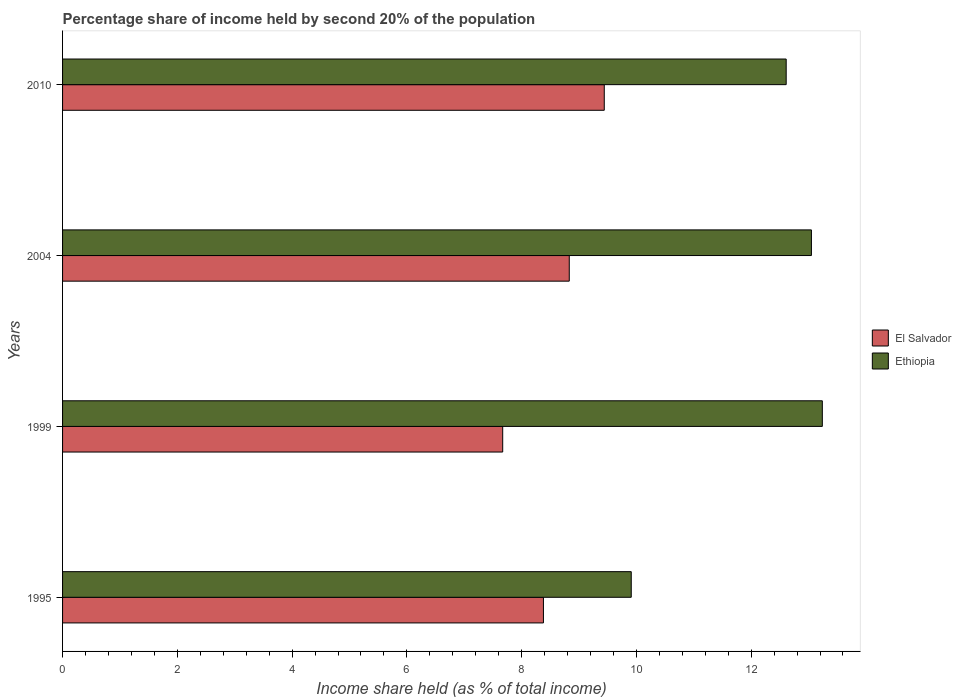How many different coloured bars are there?
Keep it short and to the point. 2. Are the number of bars per tick equal to the number of legend labels?
Offer a terse response. Yes. Are the number of bars on each tick of the Y-axis equal?
Keep it short and to the point. Yes. How many bars are there on the 3rd tick from the top?
Keep it short and to the point. 2. What is the label of the 3rd group of bars from the top?
Ensure brevity in your answer.  1999. What is the share of income held by second 20% of the population in Ethiopia in 2004?
Your answer should be compact. 13.05. Across all years, what is the maximum share of income held by second 20% of the population in Ethiopia?
Give a very brief answer. 13.24. Across all years, what is the minimum share of income held by second 20% of the population in Ethiopia?
Your answer should be compact. 9.91. In which year was the share of income held by second 20% of the population in Ethiopia maximum?
Keep it short and to the point. 1999. What is the total share of income held by second 20% of the population in Ethiopia in the graph?
Provide a short and direct response. 48.81. What is the difference between the share of income held by second 20% of the population in Ethiopia in 2004 and that in 2010?
Provide a short and direct response. 0.44. What is the difference between the share of income held by second 20% of the population in Ethiopia in 2010 and the share of income held by second 20% of the population in El Salvador in 1995?
Provide a succinct answer. 4.23. What is the average share of income held by second 20% of the population in Ethiopia per year?
Provide a succinct answer. 12.2. In the year 1999, what is the difference between the share of income held by second 20% of the population in Ethiopia and share of income held by second 20% of the population in El Salvador?
Keep it short and to the point. 5.57. In how many years, is the share of income held by second 20% of the population in Ethiopia greater than 5.6 %?
Your response must be concise. 4. What is the ratio of the share of income held by second 20% of the population in El Salvador in 1999 to that in 2004?
Ensure brevity in your answer.  0.87. Is the share of income held by second 20% of the population in El Salvador in 1999 less than that in 2004?
Provide a succinct answer. Yes. Is the difference between the share of income held by second 20% of the population in Ethiopia in 1999 and 2010 greater than the difference between the share of income held by second 20% of the population in El Salvador in 1999 and 2010?
Give a very brief answer. Yes. What is the difference between the highest and the second highest share of income held by second 20% of the population in El Salvador?
Offer a terse response. 0.61. What is the difference between the highest and the lowest share of income held by second 20% of the population in Ethiopia?
Keep it short and to the point. 3.33. In how many years, is the share of income held by second 20% of the population in El Salvador greater than the average share of income held by second 20% of the population in El Salvador taken over all years?
Provide a short and direct response. 2. What does the 1st bar from the top in 2004 represents?
Give a very brief answer. Ethiopia. What does the 2nd bar from the bottom in 2010 represents?
Your answer should be very brief. Ethiopia. What is the difference between two consecutive major ticks on the X-axis?
Your answer should be compact. 2. Does the graph contain any zero values?
Keep it short and to the point. No. Does the graph contain grids?
Make the answer very short. No. How many legend labels are there?
Provide a short and direct response. 2. What is the title of the graph?
Keep it short and to the point. Percentage share of income held by second 20% of the population. What is the label or title of the X-axis?
Your answer should be compact. Income share held (as % of total income). What is the Income share held (as % of total income) of El Salvador in 1995?
Your response must be concise. 8.38. What is the Income share held (as % of total income) of Ethiopia in 1995?
Offer a terse response. 9.91. What is the Income share held (as % of total income) of El Salvador in 1999?
Make the answer very short. 7.67. What is the Income share held (as % of total income) in Ethiopia in 1999?
Provide a short and direct response. 13.24. What is the Income share held (as % of total income) of El Salvador in 2004?
Ensure brevity in your answer.  8.83. What is the Income share held (as % of total income) in Ethiopia in 2004?
Offer a very short reply. 13.05. What is the Income share held (as % of total income) in El Salvador in 2010?
Make the answer very short. 9.44. What is the Income share held (as % of total income) in Ethiopia in 2010?
Your response must be concise. 12.61. Across all years, what is the maximum Income share held (as % of total income) in El Salvador?
Provide a succinct answer. 9.44. Across all years, what is the maximum Income share held (as % of total income) in Ethiopia?
Your answer should be compact. 13.24. Across all years, what is the minimum Income share held (as % of total income) in El Salvador?
Your answer should be very brief. 7.67. Across all years, what is the minimum Income share held (as % of total income) of Ethiopia?
Your answer should be very brief. 9.91. What is the total Income share held (as % of total income) of El Salvador in the graph?
Your answer should be very brief. 34.32. What is the total Income share held (as % of total income) in Ethiopia in the graph?
Offer a very short reply. 48.81. What is the difference between the Income share held (as % of total income) of El Salvador in 1995 and that in 1999?
Keep it short and to the point. 0.71. What is the difference between the Income share held (as % of total income) in Ethiopia in 1995 and that in 1999?
Your answer should be compact. -3.33. What is the difference between the Income share held (as % of total income) in El Salvador in 1995 and that in 2004?
Make the answer very short. -0.45. What is the difference between the Income share held (as % of total income) of Ethiopia in 1995 and that in 2004?
Offer a very short reply. -3.14. What is the difference between the Income share held (as % of total income) of El Salvador in 1995 and that in 2010?
Ensure brevity in your answer.  -1.06. What is the difference between the Income share held (as % of total income) in El Salvador in 1999 and that in 2004?
Give a very brief answer. -1.16. What is the difference between the Income share held (as % of total income) in Ethiopia in 1999 and that in 2004?
Provide a short and direct response. 0.19. What is the difference between the Income share held (as % of total income) of El Salvador in 1999 and that in 2010?
Your answer should be very brief. -1.77. What is the difference between the Income share held (as % of total income) of Ethiopia in 1999 and that in 2010?
Your answer should be compact. 0.63. What is the difference between the Income share held (as % of total income) of El Salvador in 2004 and that in 2010?
Ensure brevity in your answer.  -0.61. What is the difference between the Income share held (as % of total income) in Ethiopia in 2004 and that in 2010?
Ensure brevity in your answer.  0.44. What is the difference between the Income share held (as % of total income) of El Salvador in 1995 and the Income share held (as % of total income) of Ethiopia in 1999?
Give a very brief answer. -4.86. What is the difference between the Income share held (as % of total income) of El Salvador in 1995 and the Income share held (as % of total income) of Ethiopia in 2004?
Your answer should be compact. -4.67. What is the difference between the Income share held (as % of total income) of El Salvador in 1995 and the Income share held (as % of total income) of Ethiopia in 2010?
Make the answer very short. -4.23. What is the difference between the Income share held (as % of total income) of El Salvador in 1999 and the Income share held (as % of total income) of Ethiopia in 2004?
Keep it short and to the point. -5.38. What is the difference between the Income share held (as % of total income) in El Salvador in 1999 and the Income share held (as % of total income) in Ethiopia in 2010?
Provide a short and direct response. -4.94. What is the difference between the Income share held (as % of total income) of El Salvador in 2004 and the Income share held (as % of total income) of Ethiopia in 2010?
Give a very brief answer. -3.78. What is the average Income share held (as % of total income) of El Salvador per year?
Your answer should be compact. 8.58. What is the average Income share held (as % of total income) in Ethiopia per year?
Ensure brevity in your answer.  12.2. In the year 1995, what is the difference between the Income share held (as % of total income) in El Salvador and Income share held (as % of total income) in Ethiopia?
Provide a short and direct response. -1.53. In the year 1999, what is the difference between the Income share held (as % of total income) in El Salvador and Income share held (as % of total income) in Ethiopia?
Your response must be concise. -5.57. In the year 2004, what is the difference between the Income share held (as % of total income) in El Salvador and Income share held (as % of total income) in Ethiopia?
Provide a succinct answer. -4.22. In the year 2010, what is the difference between the Income share held (as % of total income) in El Salvador and Income share held (as % of total income) in Ethiopia?
Give a very brief answer. -3.17. What is the ratio of the Income share held (as % of total income) of El Salvador in 1995 to that in 1999?
Offer a very short reply. 1.09. What is the ratio of the Income share held (as % of total income) of Ethiopia in 1995 to that in 1999?
Offer a very short reply. 0.75. What is the ratio of the Income share held (as % of total income) of El Salvador in 1995 to that in 2004?
Keep it short and to the point. 0.95. What is the ratio of the Income share held (as % of total income) of Ethiopia in 1995 to that in 2004?
Provide a succinct answer. 0.76. What is the ratio of the Income share held (as % of total income) in El Salvador in 1995 to that in 2010?
Offer a very short reply. 0.89. What is the ratio of the Income share held (as % of total income) in Ethiopia in 1995 to that in 2010?
Offer a terse response. 0.79. What is the ratio of the Income share held (as % of total income) of El Salvador in 1999 to that in 2004?
Your answer should be compact. 0.87. What is the ratio of the Income share held (as % of total income) in Ethiopia in 1999 to that in 2004?
Provide a short and direct response. 1.01. What is the ratio of the Income share held (as % of total income) in El Salvador in 1999 to that in 2010?
Give a very brief answer. 0.81. What is the ratio of the Income share held (as % of total income) in El Salvador in 2004 to that in 2010?
Offer a very short reply. 0.94. What is the ratio of the Income share held (as % of total income) in Ethiopia in 2004 to that in 2010?
Provide a succinct answer. 1.03. What is the difference between the highest and the second highest Income share held (as % of total income) of El Salvador?
Your answer should be very brief. 0.61. What is the difference between the highest and the second highest Income share held (as % of total income) of Ethiopia?
Your answer should be very brief. 0.19. What is the difference between the highest and the lowest Income share held (as % of total income) in El Salvador?
Your response must be concise. 1.77. What is the difference between the highest and the lowest Income share held (as % of total income) in Ethiopia?
Provide a succinct answer. 3.33. 